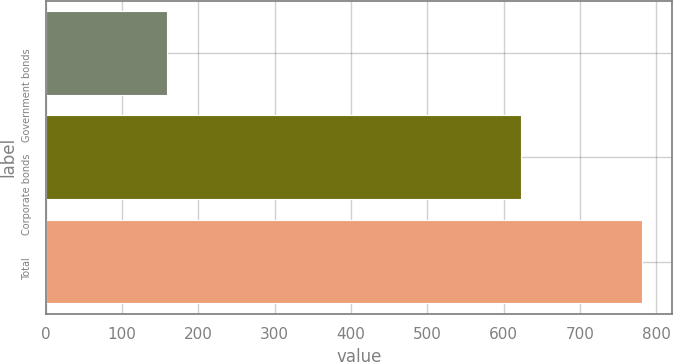<chart> <loc_0><loc_0><loc_500><loc_500><bar_chart><fcel>Government bonds<fcel>Corporate bonds<fcel>Total<nl><fcel>159<fcel>622<fcel>781<nl></chart> 